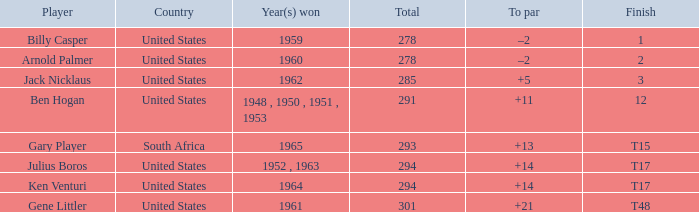What are the winning year(s) when the total is lesser than 285? 1959, 1960. 